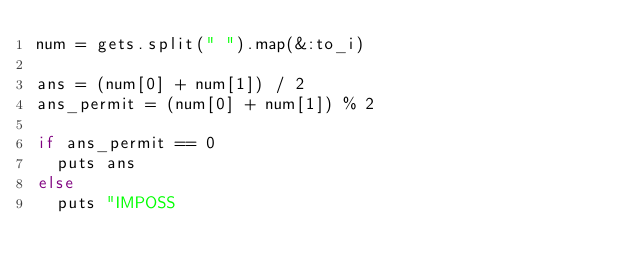<code> <loc_0><loc_0><loc_500><loc_500><_Ruby_>num = gets.split(" ").map(&:to_i)

ans = (num[0] + num[1]) / 2
ans_permit = (num[0] + num[1]) % 2

if ans_permit == 0
  puts ans
else
  puts "IMPOSS</code> 